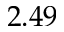<formula> <loc_0><loc_0><loc_500><loc_500>2 . 4 9</formula> 